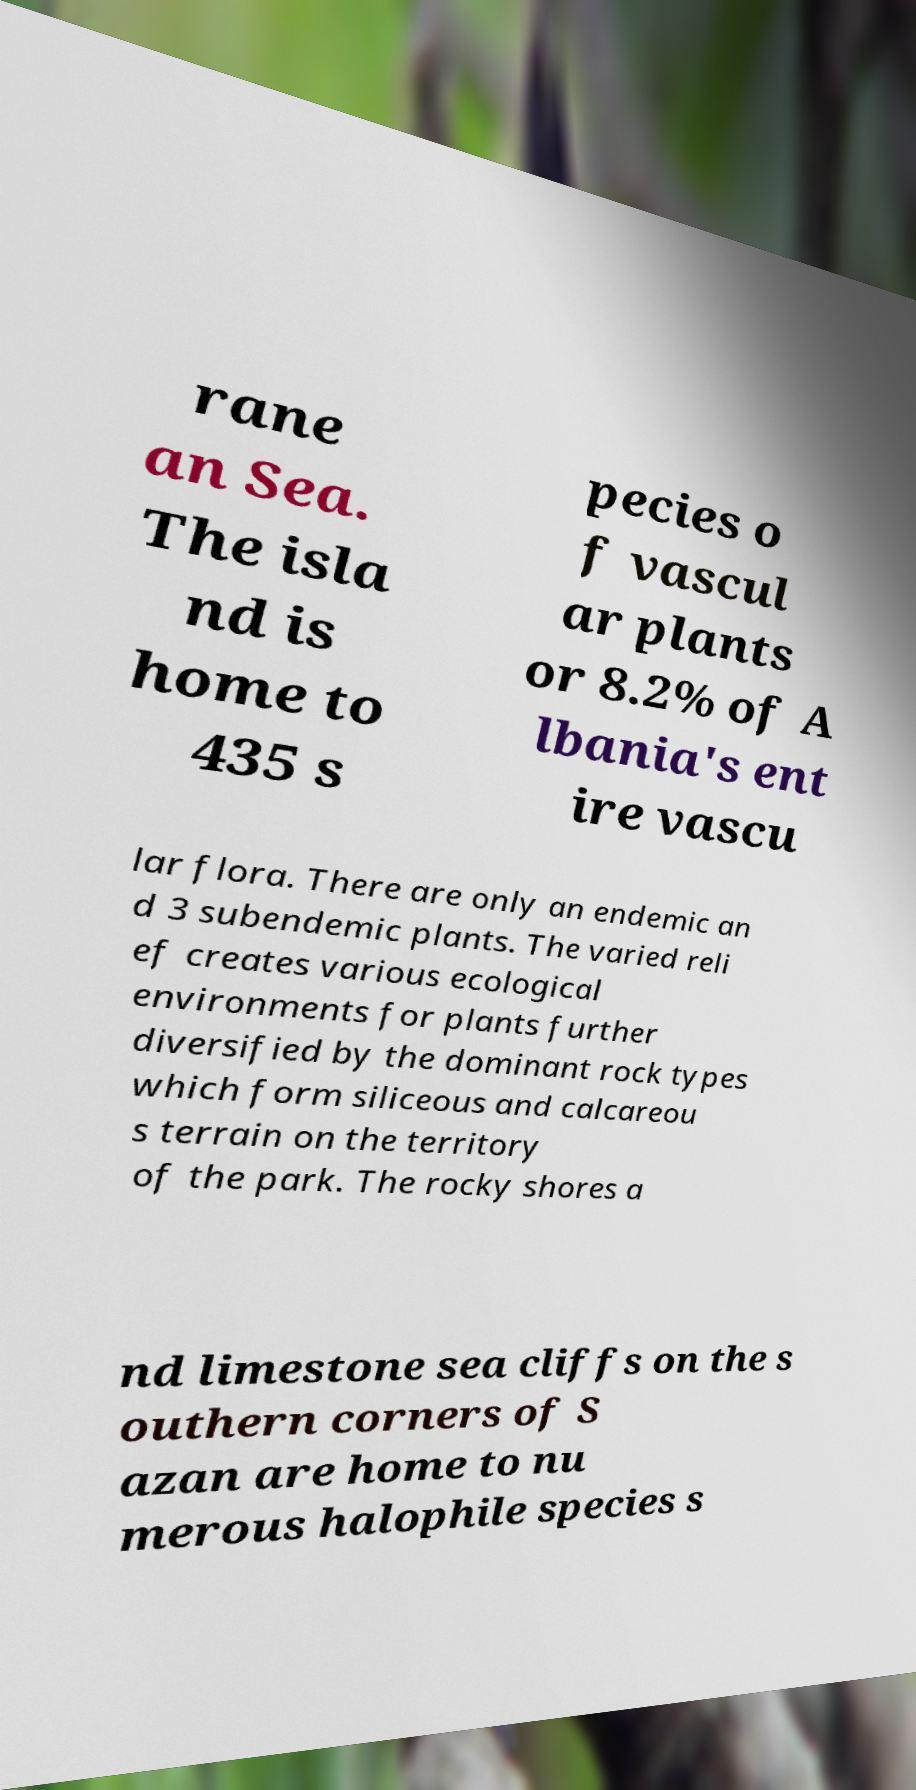Can you accurately transcribe the text from the provided image for me? rane an Sea. The isla nd is home to 435 s pecies o f vascul ar plants or 8.2% of A lbania's ent ire vascu lar flora. There are only an endemic an d 3 subendemic plants. The varied reli ef creates various ecological environments for plants further diversified by the dominant rock types which form siliceous and calcareou s terrain on the territory of the park. The rocky shores a nd limestone sea cliffs on the s outhern corners of S azan are home to nu merous halophile species s 